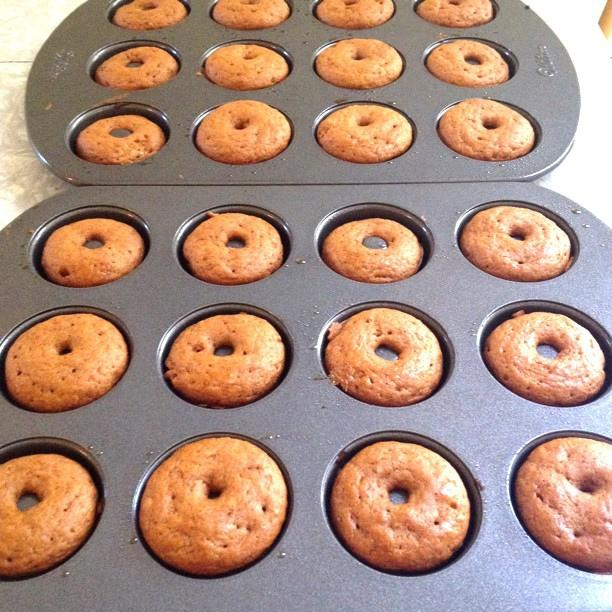What color are the donuts made from this strange pan? brown 